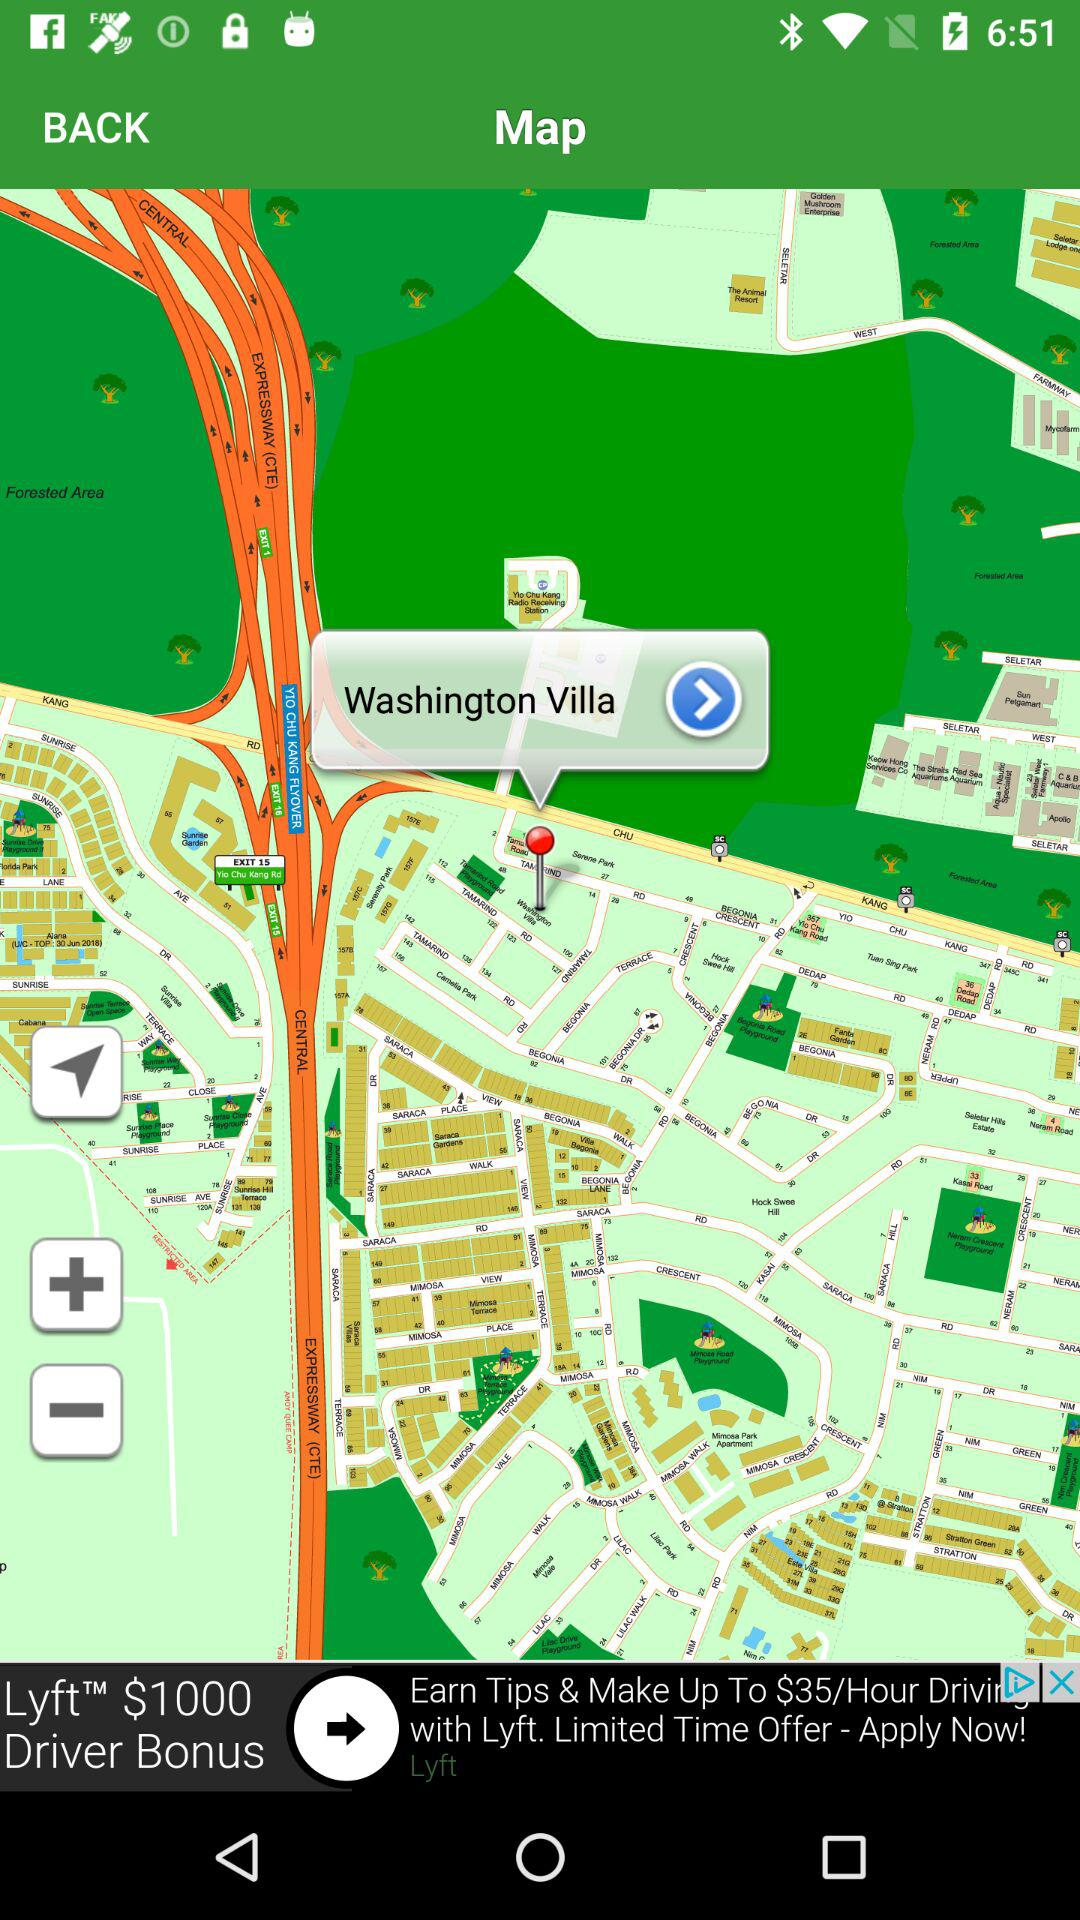What is the search location? The searched location is Washington Villa. 